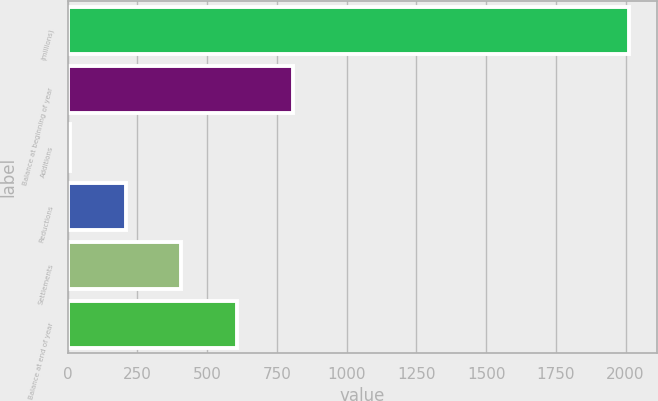Convert chart to OTSL. <chart><loc_0><loc_0><loc_500><loc_500><bar_chart><fcel>(millions)<fcel>Balance at beginning of year<fcel>Additions<fcel>Reductions<fcel>Settlements<fcel>Balance at end of year<nl><fcel>2011<fcel>808.6<fcel>7<fcel>207.4<fcel>407.8<fcel>608.2<nl></chart> 